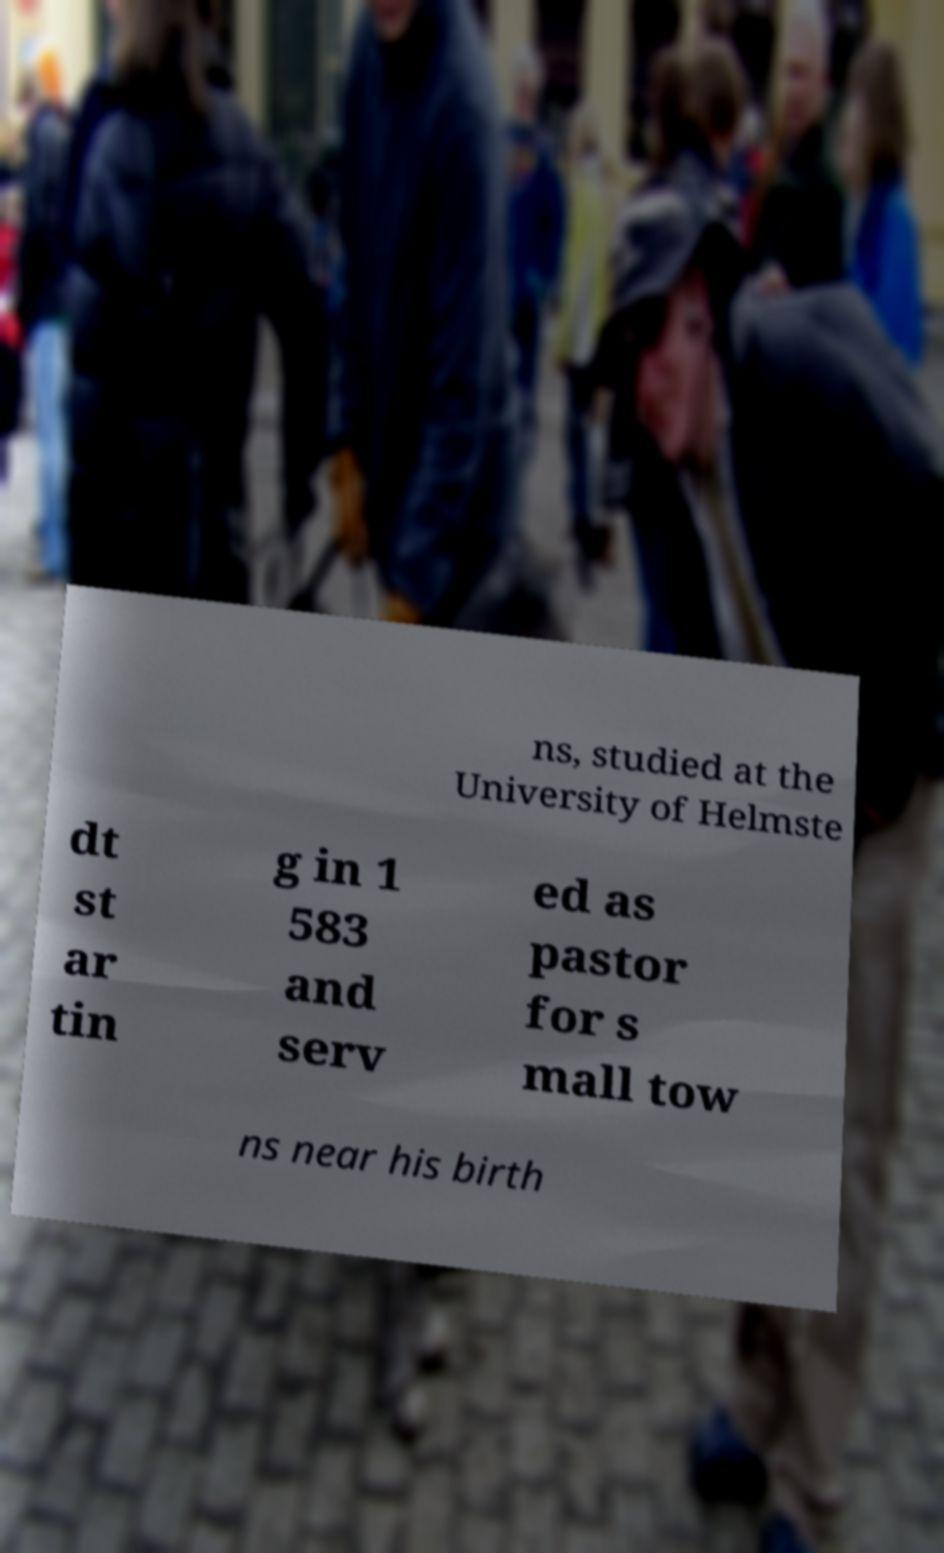I need the written content from this picture converted into text. Can you do that? ns, studied at the University of Helmste dt st ar tin g in 1 583 and serv ed as pastor for s mall tow ns near his birth 